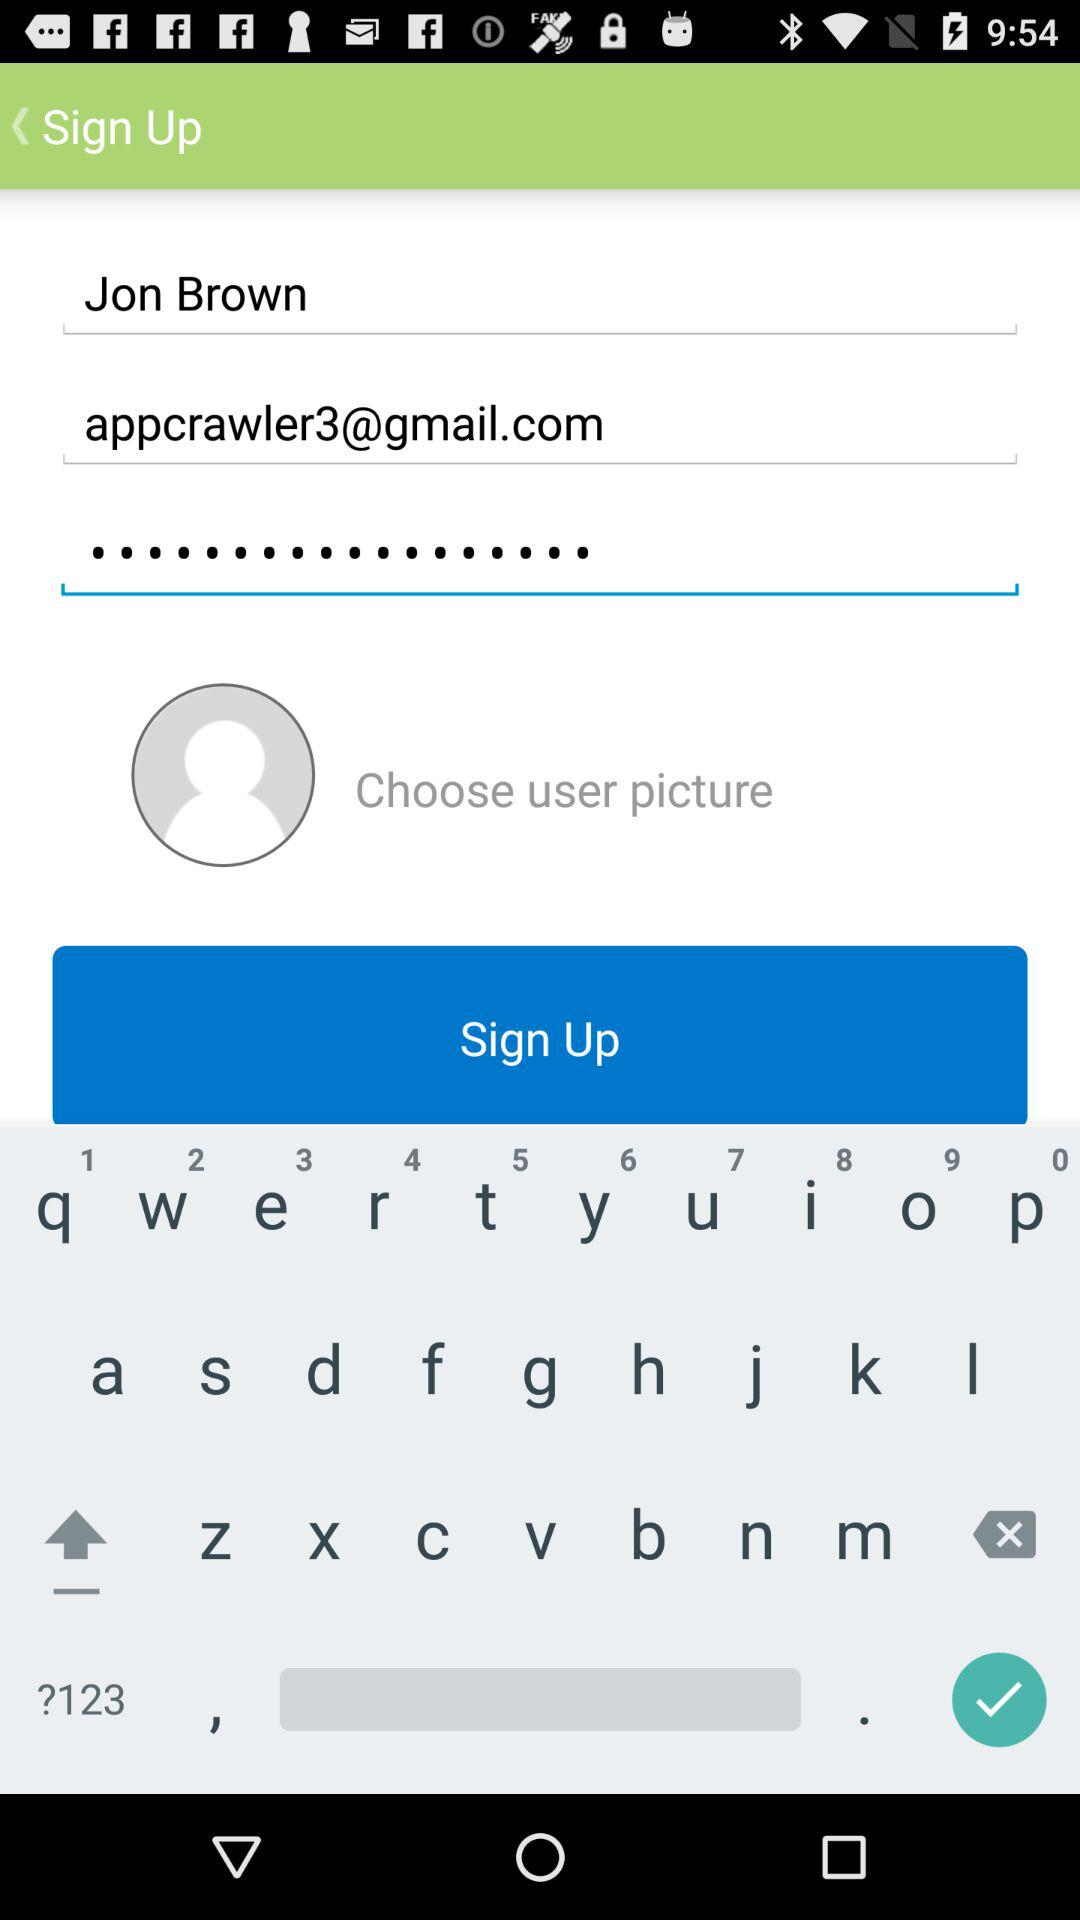How many text fields are there in the sign up form?
Answer the question using a single word or phrase. 3 